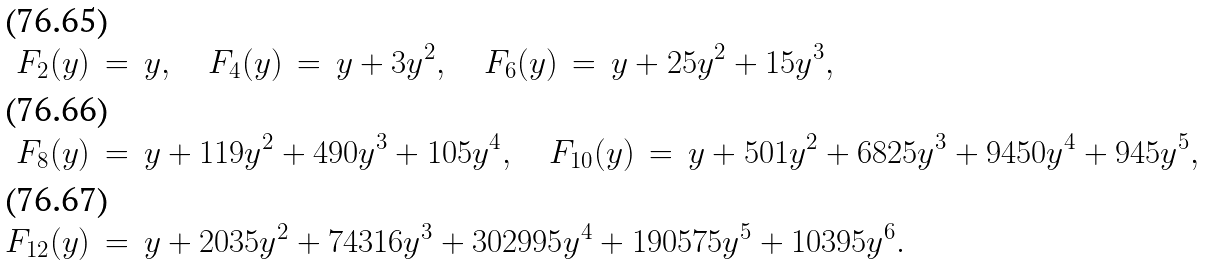Convert formula to latex. <formula><loc_0><loc_0><loc_500><loc_500>F _ { 2 } ( y ) \, & = \, y , \quad F _ { 4 } ( y ) \, = \, y + 3 y ^ { 2 } , \quad F _ { 6 } ( y ) \, = \, y + 2 5 y ^ { 2 } + 1 5 y ^ { 3 } , \\ F _ { 8 } ( y ) \, & = \, y + 1 1 9 y ^ { 2 } + 4 9 0 y ^ { 3 } + 1 0 5 y ^ { 4 } , \quad F _ { 1 0 } ( y ) \, = \, y + 5 0 1 y ^ { 2 } + 6 8 2 5 y ^ { 3 } + 9 4 5 0 y ^ { 4 } + 9 4 5 y ^ { 5 } , \\ F _ { 1 2 } ( y ) \, & = \, y + 2 0 3 5 y ^ { 2 } + 7 4 3 1 6 y ^ { 3 } + 3 0 2 9 9 5 y ^ { 4 } + 1 9 0 5 7 5 y ^ { 5 } + 1 0 3 9 5 y ^ { 6 } .</formula> 